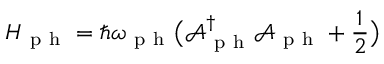Convert formula to latex. <formula><loc_0><loc_0><loc_500><loc_500>H _ { p h } = \hbar { \omega } _ { p h } \left ( \mathcal { A } _ { p h } ^ { \dagger } \mathcal { A } _ { p h } + \frac { 1 } { 2 } \right )</formula> 